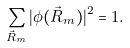<formula> <loc_0><loc_0><loc_500><loc_500>\sum _ { \vec { R } _ { m } } | \phi ( \vec { R } _ { m } ) | ^ { 2 } = 1 .</formula> 